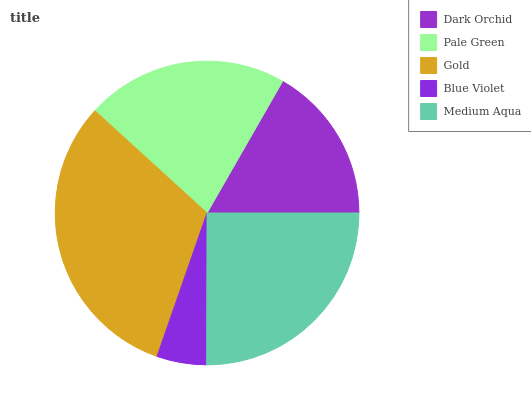Is Blue Violet the minimum?
Answer yes or no. Yes. Is Gold the maximum?
Answer yes or no. Yes. Is Pale Green the minimum?
Answer yes or no. No. Is Pale Green the maximum?
Answer yes or no. No. Is Pale Green greater than Dark Orchid?
Answer yes or no. Yes. Is Dark Orchid less than Pale Green?
Answer yes or no. Yes. Is Dark Orchid greater than Pale Green?
Answer yes or no. No. Is Pale Green less than Dark Orchid?
Answer yes or no. No. Is Pale Green the high median?
Answer yes or no. Yes. Is Pale Green the low median?
Answer yes or no. Yes. Is Medium Aqua the high median?
Answer yes or no. No. Is Gold the low median?
Answer yes or no. No. 